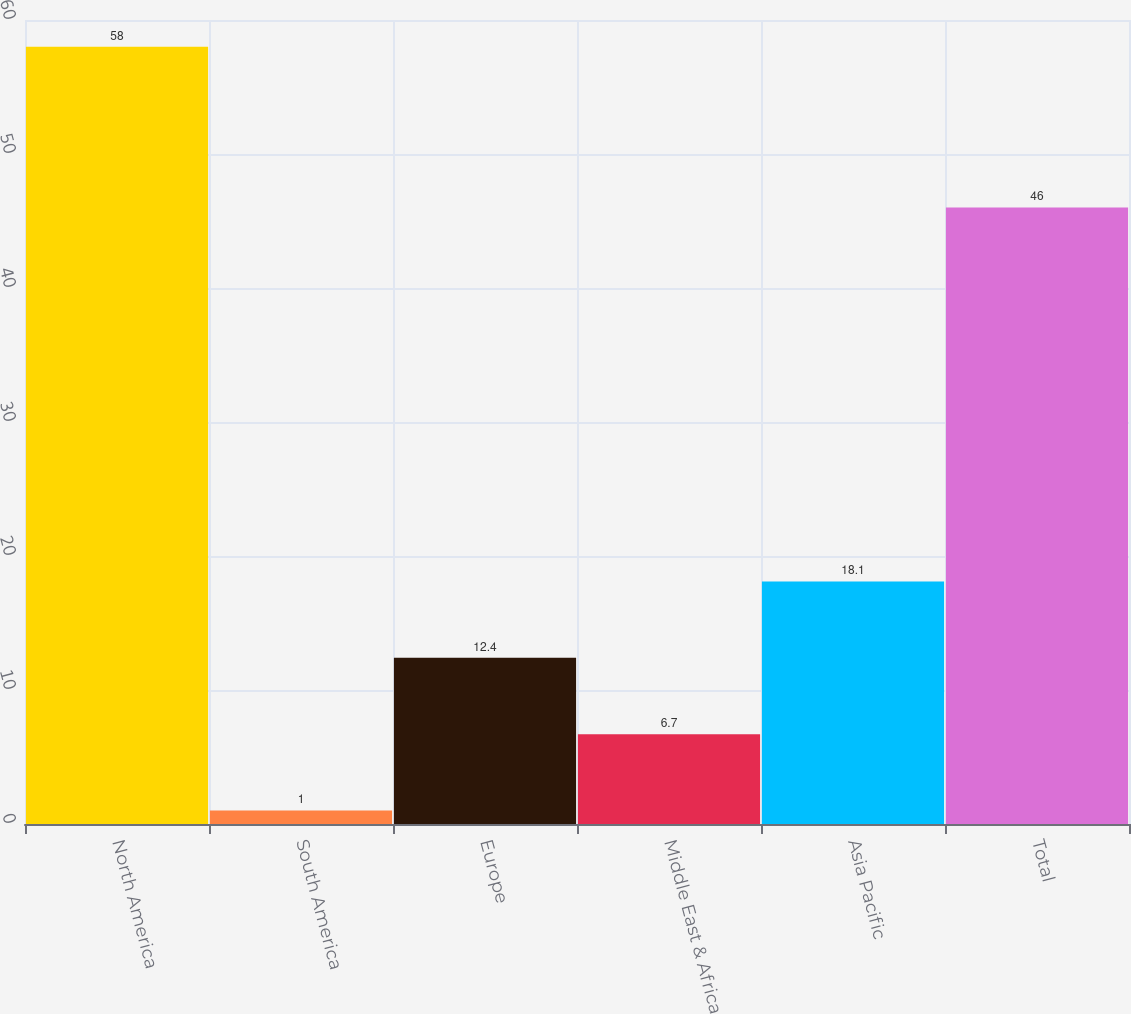Convert chart. <chart><loc_0><loc_0><loc_500><loc_500><bar_chart><fcel>North America<fcel>South America<fcel>Europe<fcel>Middle East & Africa<fcel>Asia Pacific<fcel>Total<nl><fcel>58<fcel>1<fcel>12.4<fcel>6.7<fcel>18.1<fcel>46<nl></chart> 